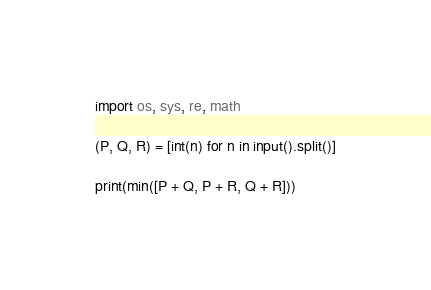<code> <loc_0><loc_0><loc_500><loc_500><_Python_>import os, sys, re, math

(P, Q, R) = [int(n) for n in input().split()]

print(min([P + Q, P + R, Q + R]))
</code> 